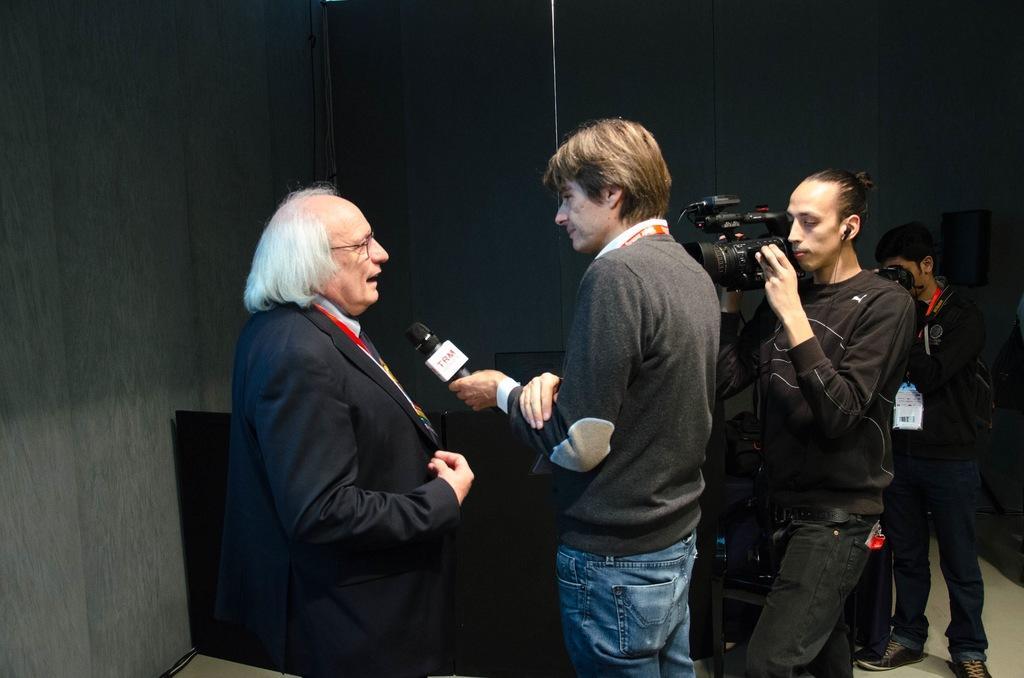In one or two sentences, can you explain what this image depicts? In this image there are four people, person with black suit is talking and person with blue jeans is holding the microphone, the other two persons are holding the camera. 